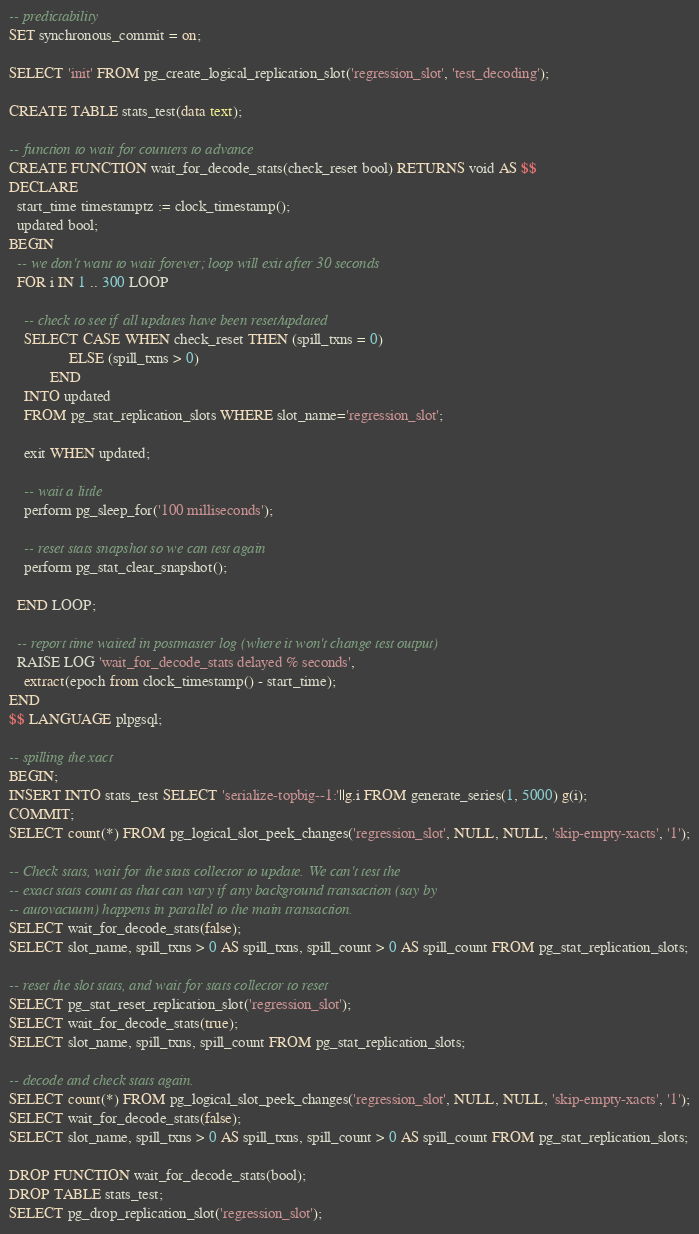<code> <loc_0><loc_0><loc_500><loc_500><_SQL_>-- predictability
SET synchronous_commit = on;

SELECT 'init' FROM pg_create_logical_replication_slot('regression_slot', 'test_decoding');

CREATE TABLE stats_test(data text);

-- function to wait for counters to advance
CREATE FUNCTION wait_for_decode_stats(check_reset bool) RETURNS void AS $$
DECLARE
  start_time timestamptz := clock_timestamp();
  updated bool;
BEGIN
  -- we don't want to wait forever; loop will exit after 30 seconds
  FOR i IN 1 .. 300 LOOP

    -- check to see if all updates have been reset/updated
    SELECT CASE WHEN check_reset THEN (spill_txns = 0)
                ELSE (spill_txns > 0)
           END
    INTO updated
    FROM pg_stat_replication_slots WHERE slot_name='regression_slot';

    exit WHEN updated;

    -- wait a little
    perform pg_sleep_for('100 milliseconds');

    -- reset stats snapshot so we can test again
    perform pg_stat_clear_snapshot();

  END LOOP;

  -- report time waited in postmaster log (where it won't change test output)
  RAISE LOG 'wait_for_decode_stats delayed % seconds',
    extract(epoch from clock_timestamp() - start_time);
END
$$ LANGUAGE plpgsql;

-- spilling the xact
BEGIN;
INSERT INTO stats_test SELECT 'serialize-topbig--1:'||g.i FROM generate_series(1, 5000) g(i);
COMMIT;
SELECT count(*) FROM pg_logical_slot_peek_changes('regression_slot', NULL, NULL, 'skip-empty-xacts', '1');

-- Check stats, wait for the stats collector to update. We can't test the
-- exact stats count as that can vary if any background transaction (say by
-- autovacuum) happens in parallel to the main transaction.
SELECT wait_for_decode_stats(false);
SELECT slot_name, spill_txns > 0 AS spill_txns, spill_count > 0 AS spill_count FROM pg_stat_replication_slots;

-- reset the slot stats, and wait for stats collector to reset
SELECT pg_stat_reset_replication_slot('regression_slot');
SELECT wait_for_decode_stats(true);
SELECT slot_name, spill_txns, spill_count FROM pg_stat_replication_slots;

-- decode and check stats again.
SELECT count(*) FROM pg_logical_slot_peek_changes('regression_slot', NULL, NULL, 'skip-empty-xacts', '1');
SELECT wait_for_decode_stats(false);
SELECT slot_name, spill_txns > 0 AS spill_txns, spill_count > 0 AS spill_count FROM pg_stat_replication_slots;

DROP FUNCTION wait_for_decode_stats(bool);
DROP TABLE stats_test;
SELECT pg_drop_replication_slot('regression_slot');
</code> 